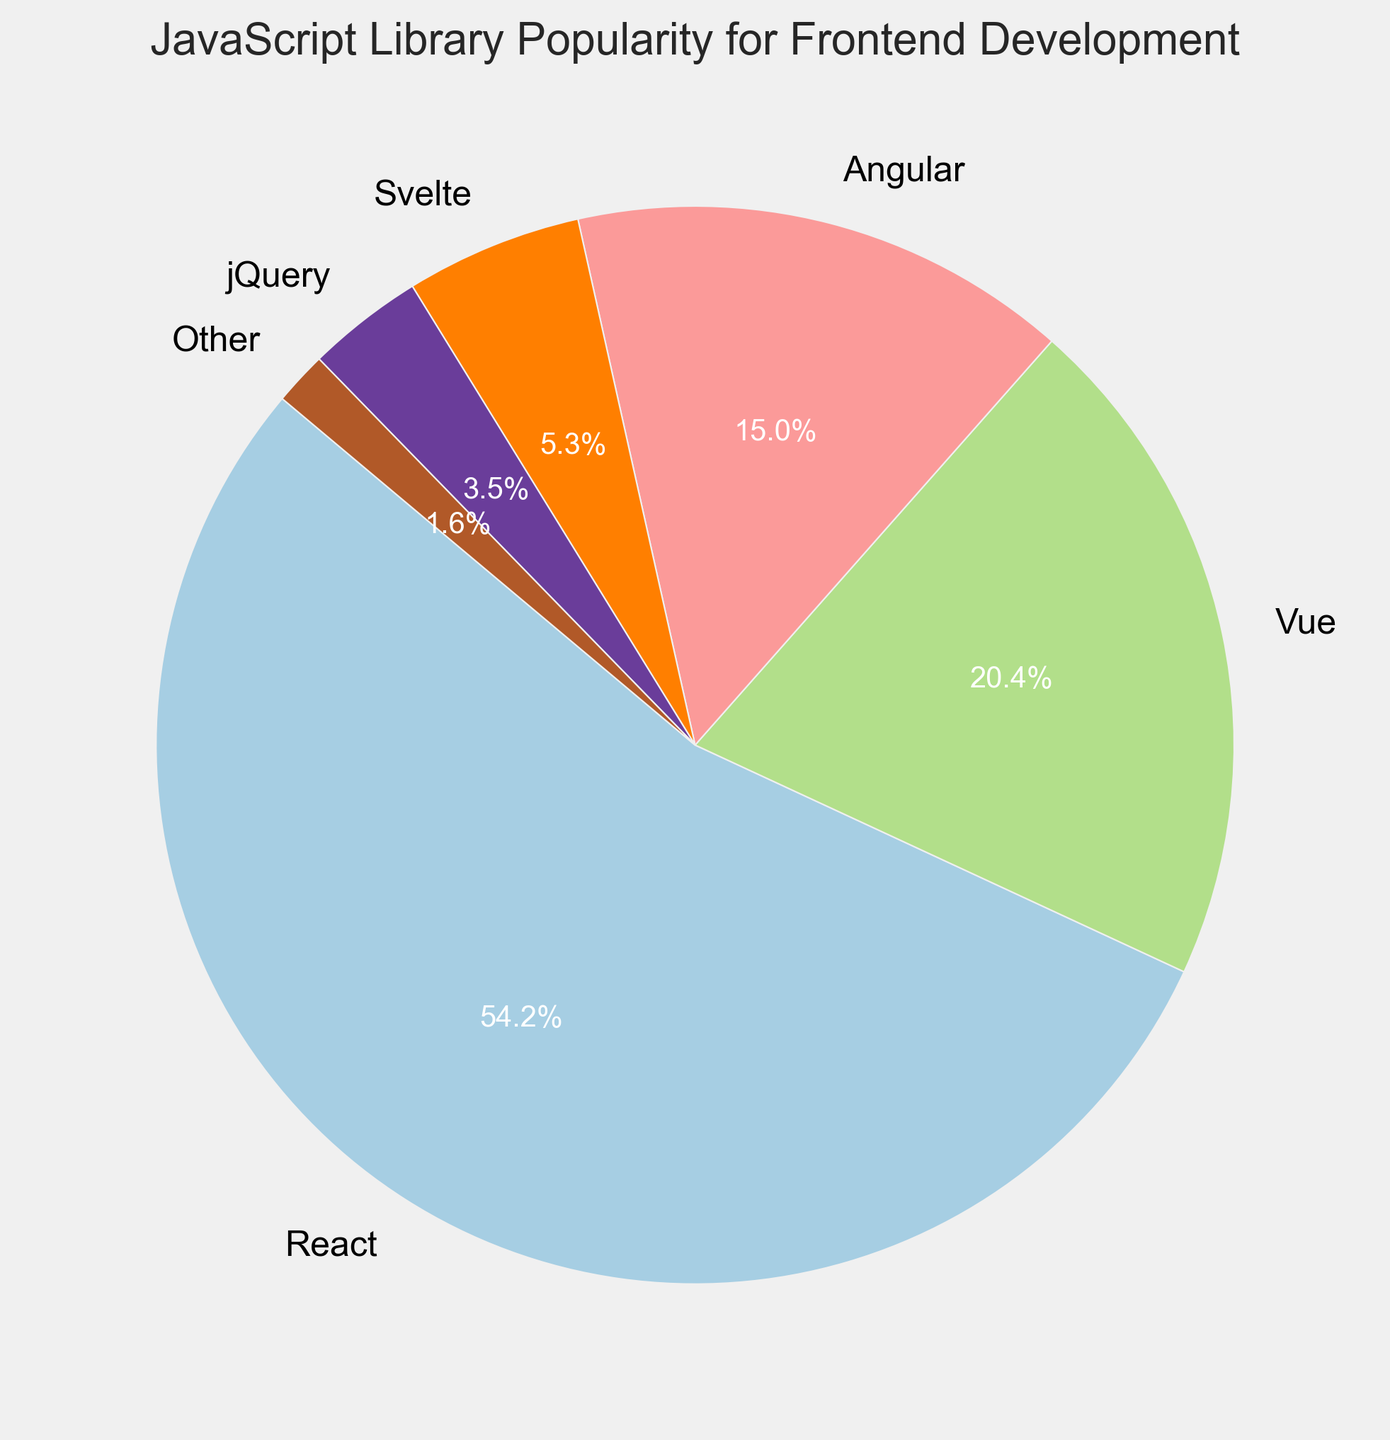What percentage of popularity does React have over Vue? React has a popularity of 54.2% and Vue has 20.4%. To find the percentage difference, you subtract the smaller percentage from the larger one: 54.2 - 20.4 = 33.8
Answer: 33.8% What is the sum of the popularity percentages for React and Angular combined? React's popularity is 54.2% and Angular's is 15.0%. Adding these together: 54.2 + 15.0 = 69.2
Answer: 69.2% Which library has the lowest popularity? By visually inspecting the pie chart segments, "Other" has the smallest wedge, corresponding to 1.6%
Answer: Other Are there more total users using Vue and Svelte together than those using Angular? Vue has 20.4%, and Svelte has 5.3%. Adding them together gives 25.7%. Since 25.7% is greater than Angular's 15%, there are more users combining Vue and Svelte than Angular alone
Answer: Yes By what margin does React's popularity exceed the combined popularity of Svelte and jQuery? React is at 54.2%, while Svelte and jQuery together sum up to 5.3 + 3.5 = 8.8%. The margin is 54.2 - 8.8 = 45.4
Answer: 45.4 What is the average popularity of all the libraries excluding React? Sum the percentages of Vue, Angular, Svelte, jQuery, and Other: 20.4 + 15.0 + 5.3 + 3.5 + 1.6 = 45.8. There are 5 libraries, so the average is 45.8 / 5 = 9.16
Answer: 9.16 Which segment of the pie chart is the largest in size? By visual inspection, the largest segment corresponds to React, which has 54.2%
Answer: React 